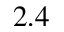Convert formula to latex. <formula><loc_0><loc_0><loc_500><loc_500>2 . 4</formula> 